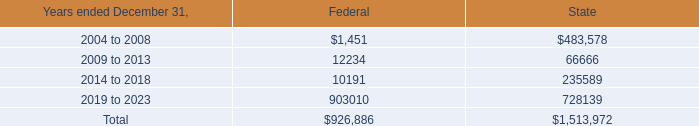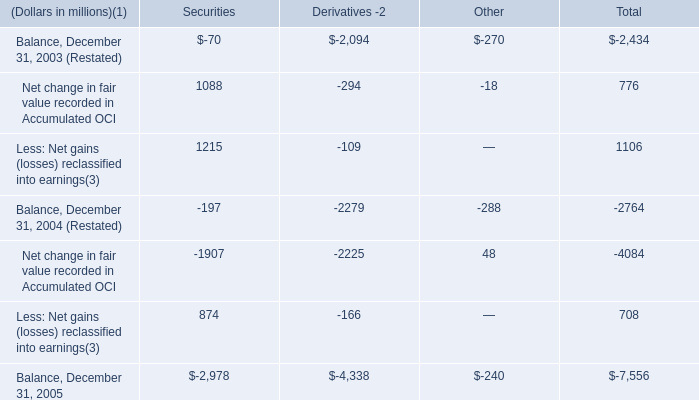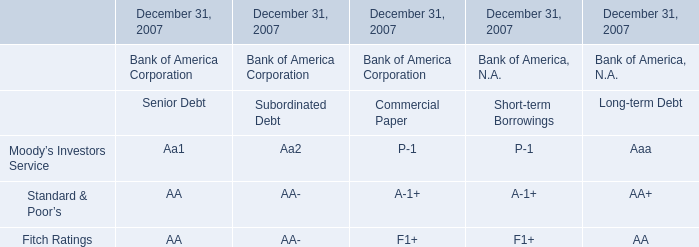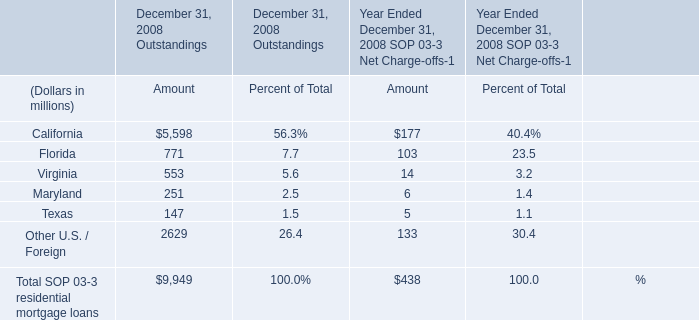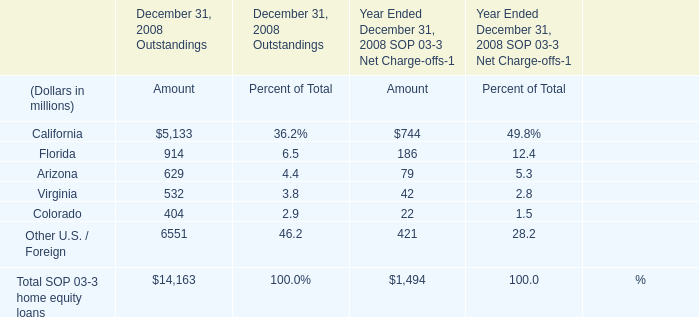at december 31 , 2003 , what was the ratio of the company net federal operating loss carry forwards to the state 
Computations: (0.9 / 1.5)
Answer: 0.6. 